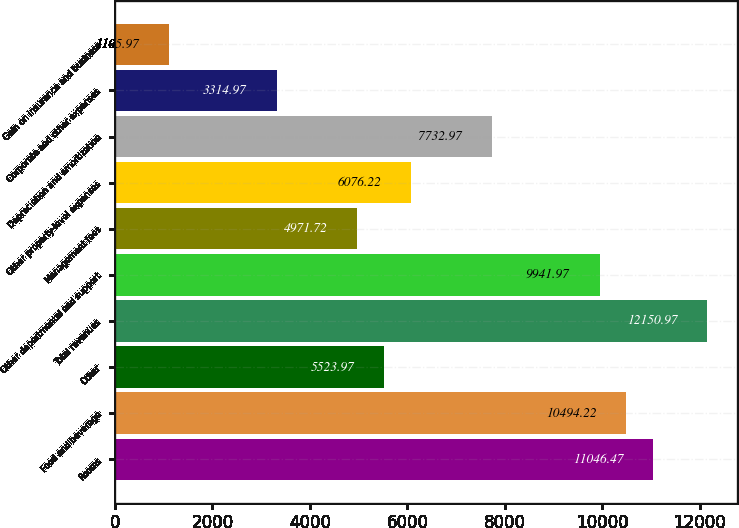Convert chart. <chart><loc_0><loc_0><loc_500><loc_500><bar_chart><fcel>Rooms<fcel>Food and beverage<fcel>Other<fcel>Total revenues<fcel>Other departmental and support<fcel>Management fees<fcel>Other property-level expenses<fcel>Depreciation and amortization<fcel>Corporate and other expenses<fcel>Gain on insurance and business<nl><fcel>11046.5<fcel>10494.2<fcel>5523.97<fcel>12151<fcel>9941.97<fcel>4971.72<fcel>6076.22<fcel>7732.97<fcel>3314.97<fcel>1105.97<nl></chart> 